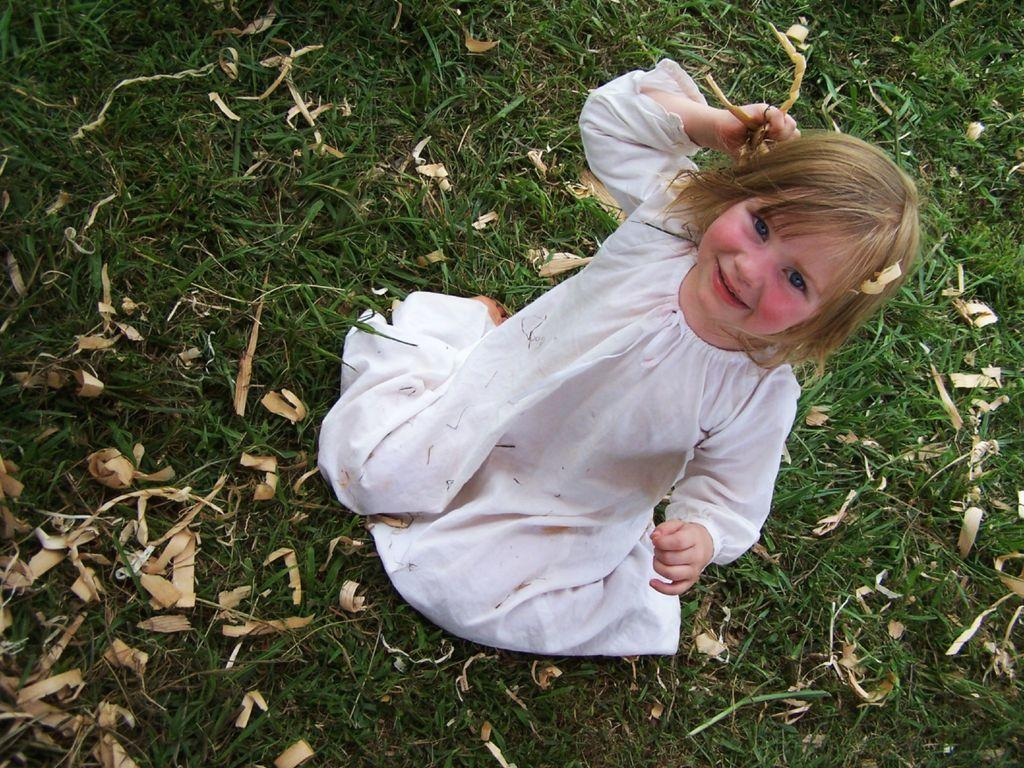Who is the main subject in the image? There is a girl in the image. What is the girl doing in the image? The girl is sitting and smiling. What type of surface is the girl sitting on? There is grass on the ground in the image. What else can be seen on the ground in the image? Dry leaves are present in the image. What type of vegetable is the girl holding in the image? There is no vegetable present in the image. 